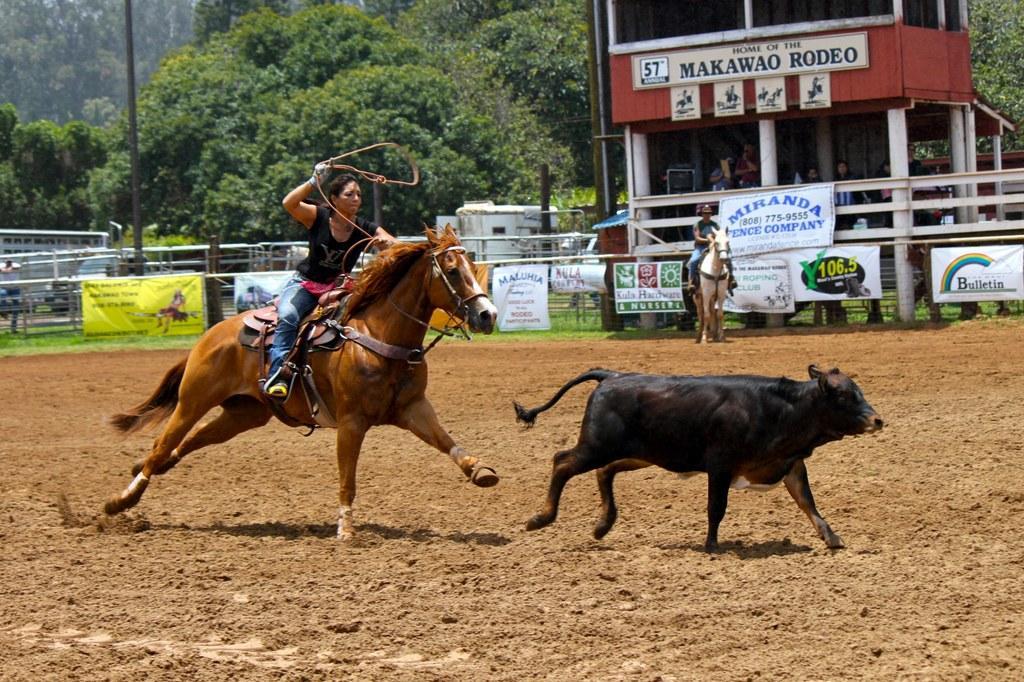Could you give a brief overview of what you see in this image? In this picture I can observe a woman riding brown color horse. In front of the horse there is an animal which is looking like a bull. I can observe another horse in the background. There are some posters in the background. I can observe some trees in the background and a pole on the left side. 